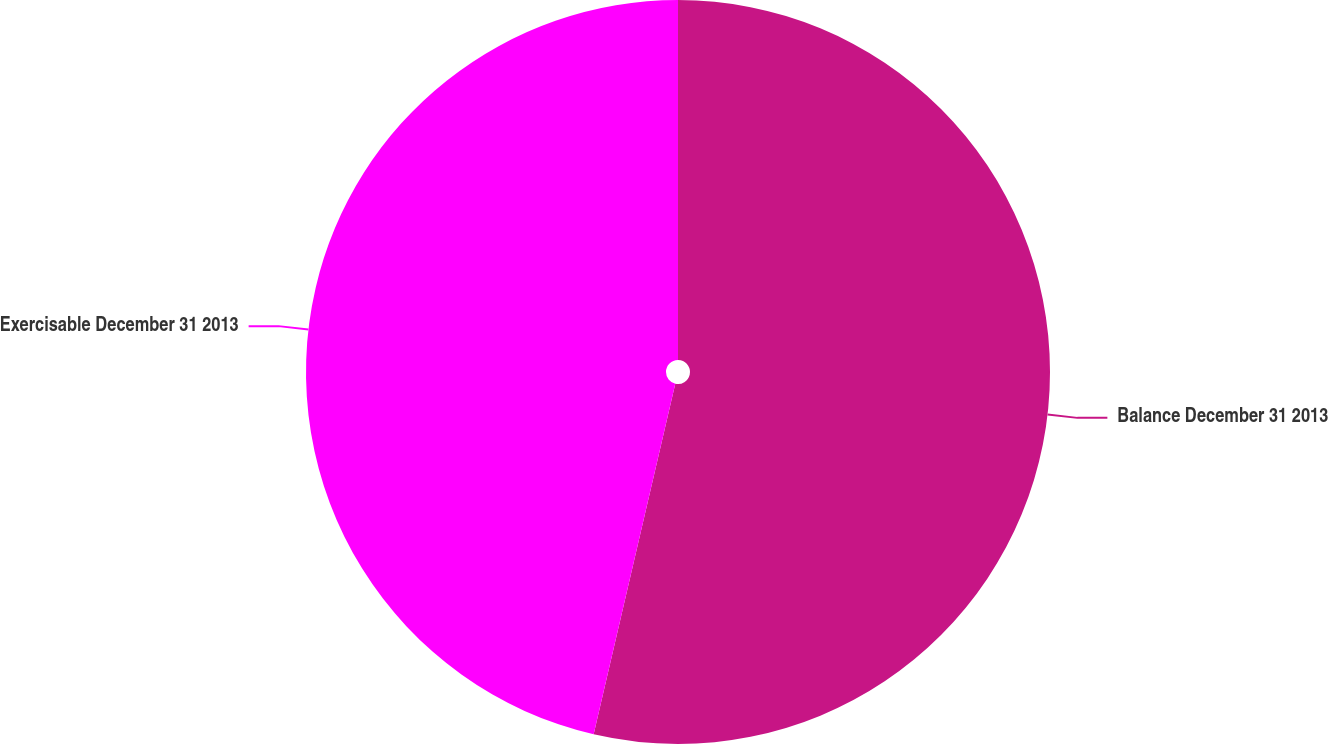Convert chart. <chart><loc_0><loc_0><loc_500><loc_500><pie_chart><fcel>Balance December 31 2013<fcel>Exercisable December 31 2013<nl><fcel>53.64%<fcel>46.36%<nl></chart> 